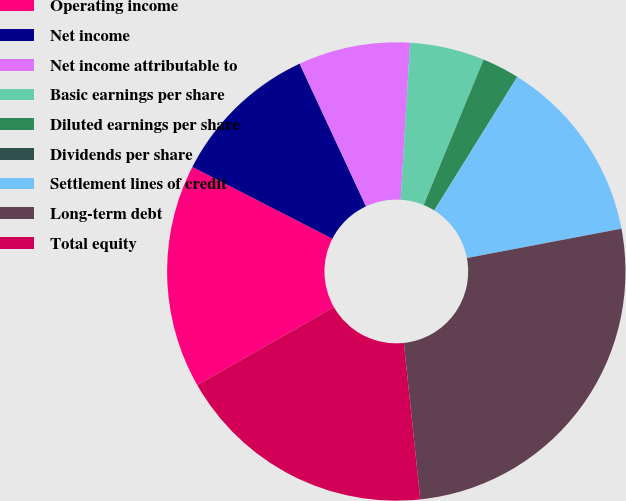Convert chart to OTSL. <chart><loc_0><loc_0><loc_500><loc_500><pie_chart><fcel>Operating income<fcel>Net income<fcel>Net income attributable to<fcel>Basic earnings per share<fcel>Diluted earnings per share<fcel>Dividends per share<fcel>Settlement lines of credit<fcel>Long-term debt<fcel>Total equity<nl><fcel>15.79%<fcel>10.53%<fcel>7.89%<fcel>5.26%<fcel>2.63%<fcel>0.0%<fcel>13.16%<fcel>26.32%<fcel>18.42%<nl></chart> 